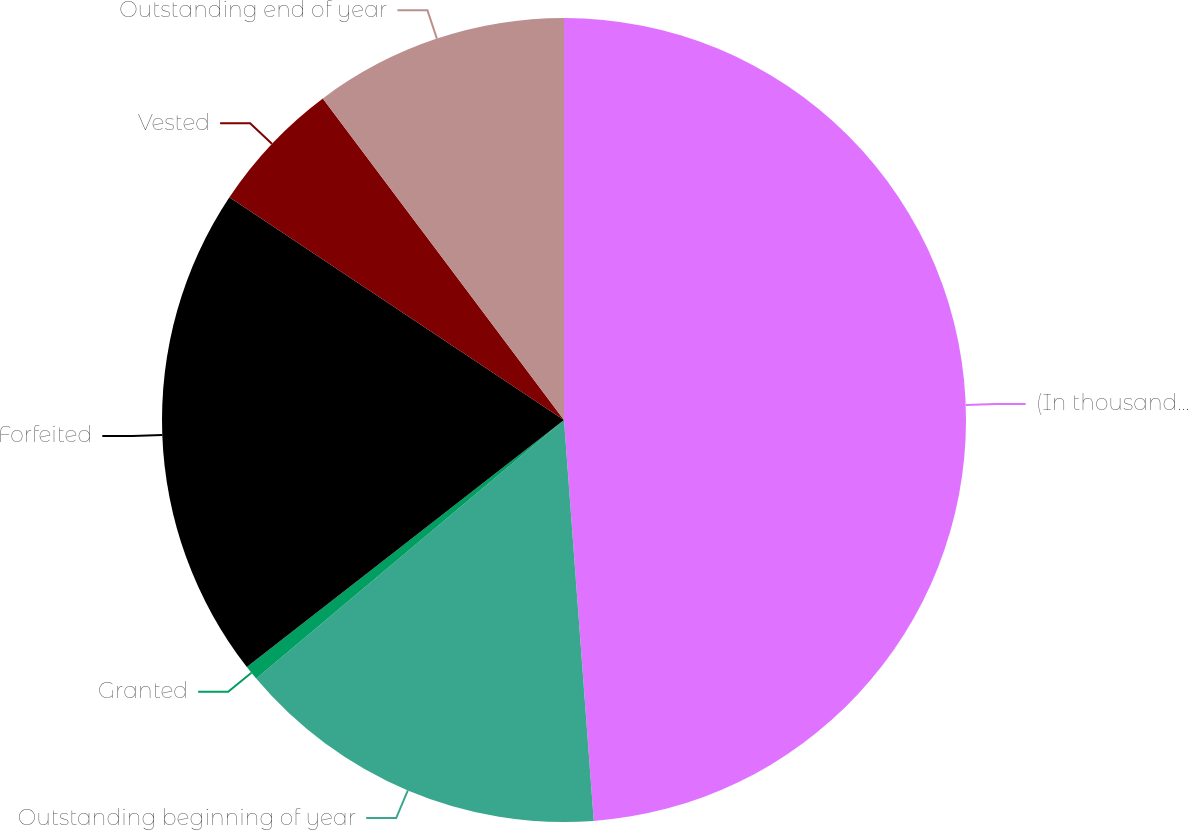Convert chart to OTSL. <chart><loc_0><loc_0><loc_500><loc_500><pie_chart><fcel>(In thousands except per share<fcel>Outstanding beginning of year<fcel>Granted<fcel>Forfeited<fcel>Vested<fcel>Outstanding end of year<nl><fcel>48.82%<fcel>15.06%<fcel>0.59%<fcel>19.88%<fcel>5.41%<fcel>10.24%<nl></chart> 